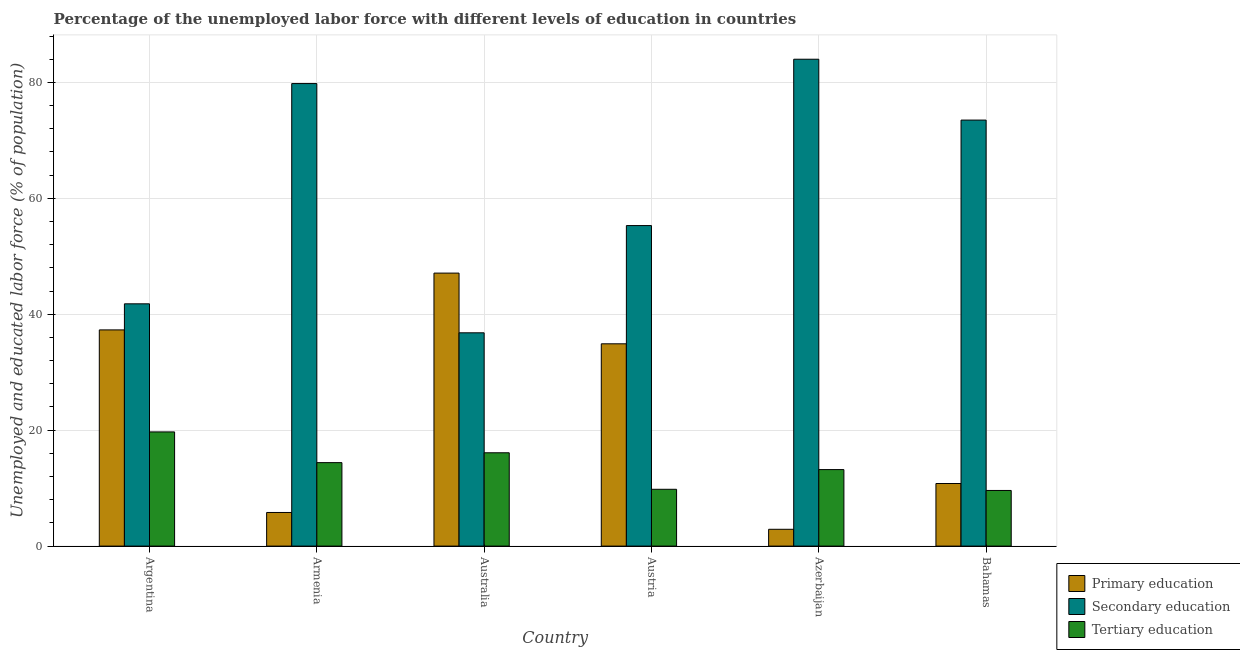How many different coloured bars are there?
Give a very brief answer. 3. How many groups of bars are there?
Provide a succinct answer. 6. How many bars are there on the 5th tick from the left?
Make the answer very short. 3. How many bars are there on the 3rd tick from the right?
Offer a very short reply. 3. What is the percentage of labor force who received secondary education in Australia?
Keep it short and to the point. 36.8. Across all countries, what is the maximum percentage of labor force who received secondary education?
Provide a short and direct response. 84. Across all countries, what is the minimum percentage of labor force who received secondary education?
Offer a terse response. 36.8. In which country was the percentage of labor force who received primary education minimum?
Ensure brevity in your answer.  Azerbaijan. What is the total percentage of labor force who received tertiary education in the graph?
Offer a terse response. 82.8. What is the difference between the percentage of labor force who received primary education in Argentina and that in Austria?
Offer a very short reply. 2.4. What is the difference between the percentage of labor force who received secondary education in Azerbaijan and the percentage of labor force who received primary education in Austria?
Your answer should be compact. 49.1. What is the average percentage of labor force who received secondary education per country?
Offer a very short reply. 61.87. What is the ratio of the percentage of labor force who received tertiary education in Azerbaijan to that in Bahamas?
Provide a succinct answer. 1.37. What is the difference between the highest and the second highest percentage of labor force who received tertiary education?
Offer a terse response. 3.6. What is the difference between the highest and the lowest percentage of labor force who received primary education?
Keep it short and to the point. 44.2. In how many countries, is the percentage of labor force who received primary education greater than the average percentage of labor force who received primary education taken over all countries?
Provide a succinct answer. 3. What does the 3rd bar from the left in Azerbaijan represents?
Keep it short and to the point. Tertiary education. What does the 2nd bar from the right in Austria represents?
Provide a succinct answer. Secondary education. Is it the case that in every country, the sum of the percentage of labor force who received primary education and percentage of labor force who received secondary education is greater than the percentage of labor force who received tertiary education?
Your answer should be very brief. Yes. How many bars are there?
Ensure brevity in your answer.  18. Are all the bars in the graph horizontal?
Your answer should be very brief. No. How many countries are there in the graph?
Make the answer very short. 6. How are the legend labels stacked?
Make the answer very short. Vertical. What is the title of the graph?
Give a very brief answer. Percentage of the unemployed labor force with different levels of education in countries. What is the label or title of the Y-axis?
Your response must be concise. Unemployed and educated labor force (% of population). What is the Unemployed and educated labor force (% of population) of Primary education in Argentina?
Your answer should be very brief. 37.3. What is the Unemployed and educated labor force (% of population) in Secondary education in Argentina?
Keep it short and to the point. 41.8. What is the Unemployed and educated labor force (% of population) in Tertiary education in Argentina?
Give a very brief answer. 19.7. What is the Unemployed and educated labor force (% of population) in Primary education in Armenia?
Offer a terse response. 5.8. What is the Unemployed and educated labor force (% of population) of Secondary education in Armenia?
Give a very brief answer. 79.8. What is the Unemployed and educated labor force (% of population) in Tertiary education in Armenia?
Keep it short and to the point. 14.4. What is the Unemployed and educated labor force (% of population) in Primary education in Australia?
Provide a short and direct response. 47.1. What is the Unemployed and educated labor force (% of population) in Secondary education in Australia?
Offer a very short reply. 36.8. What is the Unemployed and educated labor force (% of population) of Tertiary education in Australia?
Offer a very short reply. 16.1. What is the Unemployed and educated labor force (% of population) in Primary education in Austria?
Offer a very short reply. 34.9. What is the Unemployed and educated labor force (% of population) in Secondary education in Austria?
Make the answer very short. 55.3. What is the Unemployed and educated labor force (% of population) of Tertiary education in Austria?
Your answer should be very brief. 9.8. What is the Unemployed and educated labor force (% of population) in Primary education in Azerbaijan?
Give a very brief answer. 2.9. What is the Unemployed and educated labor force (% of population) in Tertiary education in Azerbaijan?
Your response must be concise. 13.2. What is the Unemployed and educated labor force (% of population) of Primary education in Bahamas?
Offer a very short reply. 10.8. What is the Unemployed and educated labor force (% of population) of Secondary education in Bahamas?
Provide a short and direct response. 73.5. What is the Unemployed and educated labor force (% of population) of Tertiary education in Bahamas?
Provide a short and direct response. 9.6. Across all countries, what is the maximum Unemployed and educated labor force (% of population) in Primary education?
Provide a succinct answer. 47.1. Across all countries, what is the maximum Unemployed and educated labor force (% of population) of Tertiary education?
Offer a terse response. 19.7. Across all countries, what is the minimum Unemployed and educated labor force (% of population) of Primary education?
Your answer should be compact. 2.9. Across all countries, what is the minimum Unemployed and educated labor force (% of population) in Secondary education?
Provide a short and direct response. 36.8. Across all countries, what is the minimum Unemployed and educated labor force (% of population) in Tertiary education?
Your answer should be compact. 9.6. What is the total Unemployed and educated labor force (% of population) in Primary education in the graph?
Offer a very short reply. 138.8. What is the total Unemployed and educated labor force (% of population) of Secondary education in the graph?
Your answer should be compact. 371.2. What is the total Unemployed and educated labor force (% of population) of Tertiary education in the graph?
Provide a short and direct response. 82.8. What is the difference between the Unemployed and educated labor force (% of population) of Primary education in Argentina and that in Armenia?
Your response must be concise. 31.5. What is the difference between the Unemployed and educated labor force (% of population) in Secondary education in Argentina and that in Armenia?
Provide a succinct answer. -38. What is the difference between the Unemployed and educated labor force (% of population) of Secondary education in Argentina and that in Australia?
Offer a terse response. 5. What is the difference between the Unemployed and educated labor force (% of population) in Secondary education in Argentina and that in Austria?
Your answer should be compact. -13.5. What is the difference between the Unemployed and educated labor force (% of population) of Primary education in Argentina and that in Azerbaijan?
Offer a terse response. 34.4. What is the difference between the Unemployed and educated labor force (% of population) in Secondary education in Argentina and that in Azerbaijan?
Your answer should be very brief. -42.2. What is the difference between the Unemployed and educated labor force (% of population) in Primary education in Argentina and that in Bahamas?
Make the answer very short. 26.5. What is the difference between the Unemployed and educated labor force (% of population) of Secondary education in Argentina and that in Bahamas?
Your answer should be compact. -31.7. What is the difference between the Unemployed and educated labor force (% of population) in Primary education in Armenia and that in Australia?
Ensure brevity in your answer.  -41.3. What is the difference between the Unemployed and educated labor force (% of population) in Tertiary education in Armenia and that in Australia?
Provide a short and direct response. -1.7. What is the difference between the Unemployed and educated labor force (% of population) in Primary education in Armenia and that in Austria?
Offer a terse response. -29.1. What is the difference between the Unemployed and educated labor force (% of population) in Primary education in Armenia and that in Azerbaijan?
Provide a short and direct response. 2.9. What is the difference between the Unemployed and educated labor force (% of population) of Primary education in Armenia and that in Bahamas?
Your answer should be very brief. -5. What is the difference between the Unemployed and educated labor force (% of population) in Secondary education in Armenia and that in Bahamas?
Provide a succinct answer. 6.3. What is the difference between the Unemployed and educated labor force (% of population) in Primary education in Australia and that in Austria?
Keep it short and to the point. 12.2. What is the difference between the Unemployed and educated labor force (% of population) of Secondary education in Australia and that in Austria?
Keep it short and to the point. -18.5. What is the difference between the Unemployed and educated labor force (% of population) in Primary education in Australia and that in Azerbaijan?
Provide a succinct answer. 44.2. What is the difference between the Unemployed and educated labor force (% of population) in Secondary education in Australia and that in Azerbaijan?
Offer a terse response. -47.2. What is the difference between the Unemployed and educated labor force (% of population) of Primary education in Australia and that in Bahamas?
Provide a short and direct response. 36.3. What is the difference between the Unemployed and educated labor force (% of population) in Secondary education in Australia and that in Bahamas?
Give a very brief answer. -36.7. What is the difference between the Unemployed and educated labor force (% of population) in Tertiary education in Australia and that in Bahamas?
Keep it short and to the point. 6.5. What is the difference between the Unemployed and educated labor force (% of population) in Secondary education in Austria and that in Azerbaijan?
Give a very brief answer. -28.7. What is the difference between the Unemployed and educated labor force (% of population) in Primary education in Austria and that in Bahamas?
Offer a very short reply. 24.1. What is the difference between the Unemployed and educated labor force (% of population) of Secondary education in Austria and that in Bahamas?
Make the answer very short. -18.2. What is the difference between the Unemployed and educated labor force (% of population) in Tertiary education in Austria and that in Bahamas?
Your response must be concise. 0.2. What is the difference between the Unemployed and educated labor force (% of population) in Primary education in Azerbaijan and that in Bahamas?
Ensure brevity in your answer.  -7.9. What is the difference between the Unemployed and educated labor force (% of population) in Tertiary education in Azerbaijan and that in Bahamas?
Provide a succinct answer. 3.6. What is the difference between the Unemployed and educated labor force (% of population) of Primary education in Argentina and the Unemployed and educated labor force (% of population) of Secondary education in Armenia?
Your response must be concise. -42.5. What is the difference between the Unemployed and educated labor force (% of population) of Primary education in Argentina and the Unemployed and educated labor force (% of population) of Tertiary education in Armenia?
Provide a short and direct response. 22.9. What is the difference between the Unemployed and educated labor force (% of population) in Secondary education in Argentina and the Unemployed and educated labor force (% of population) in Tertiary education in Armenia?
Your answer should be very brief. 27.4. What is the difference between the Unemployed and educated labor force (% of population) in Primary education in Argentina and the Unemployed and educated labor force (% of population) in Secondary education in Australia?
Your answer should be very brief. 0.5. What is the difference between the Unemployed and educated labor force (% of population) of Primary education in Argentina and the Unemployed and educated labor force (% of population) of Tertiary education in Australia?
Provide a succinct answer. 21.2. What is the difference between the Unemployed and educated labor force (% of population) of Secondary education in Argentina and the Unemployed and educated labor force (% of population) of Tertiary education in Australia?
Offer a very short reply. 25.7. What is the difference between the Unemployed and educated labor force (% of population) in Primary education in Argentina and the Unemployed and educated labor force (% of population) in Secondary education in Austria?
Your answer should be compact. -18. What is the difference between the Unemployed and educated labor force (% of population) in Primary education in Argentina and the Unemployed and educated labor force (% of population) in Tertiary education in Austria?
Provide a short and direct response. 27.5. What is the difference between the Unemployed and educated labor force (% of population) of Secondary education in Argentina and the Unemployed and educated labor force (% of population) of Tertiary education in Austria?
Provide a succinct answer. 32. What is the difference between the Unemployed and educated labor force (% of population) of Primary education in Argentina and the Unemployed and educated labor force (% of population) of Secondary education in Azerbaijan?
Your answer should be very brief. -46.7. What is the difference between the Unemployed and educated labor force (% of population) in Primary education in Argentina and the Unemployed and educated labor force (% of population) in Tertiary education in Azerbaijan?
Keep it short and to the point. 24.1. What is the difference between the Unemployed and educated labor force (% of population) in Secondary education in Argentina and the Unemployed and educated labor force (% of population) in Tertiary education in Azerbaijan?
Offer a very short reply. 28.6. What is the difference between the Unemployed and educated labor force (% of population) of Primary education in Argentina and the Unemployed and educated labor force (% of population) of Secondary education in Bahamas?
Keep it short and to the point. -36.2. What is the difference between the Unemployed and educated labor force (% of population) of Primary education in Argentina and the Unemployed and educated labor force (% of population) of Tertiary education in Bahamas?
Offer a very short reply. 27.7. What is the difference between the Unemployed and educated labor force (% of population) of Secondary education in Argentina and the Unemployed and educated labor force (% of population) of Tertiary education in Bahamas?
Offer a terse response. 32.2. What is the difference between the Unemployed and educated labor force (% of population) of Primary education in Armenia and the Unemployed and educated labor force (% of population) of Secondary education in Australia?
Offer a terse response. -31. What is the difference between the Unemployed and educated labor force (% of population) of Secondary education in Armenia and the Unemployed and educated labor force (% of population) of Tertiary education in Australia?
Your response must be concise. 63.7. What is the difference between the Unemployed and educated labor force (% of population) in Primary education in Armenia and the Unemployed and educated labor force (% of population) in Secondary education in Austria?
Ensure brevity in your answer.  -49.5. What is the difference between the Unemployed and educated labor force (% of population) of Primary education in Armenia and the Unemployed and educated labor force (% of population) of Secondary education in Azerbaijan?
Offer a very short reply. -78.2. What is the difference between the Unemployed and educated labor force (% of population) in Primary education in Armenia and the Unemployed and educated labor force (% of population) in Tertiary education in Azerbaijan?
Offer a very short reply. -7.4. What is the difference between the Unemployed and educated labor force (% of population) in Secondary education in Armenia and the Unemployed and educated labor force (% of population) in Tertiary education in Azerbaijan?
Make the answer very short. 66.6. What is the difference between the Unemployed and educated labor force (% of population) of Primary education in Armenia and the Unemployed and educated labor force (% of population) of Secondary education in Bahamas?
Your response must be concise. -67.7. What is the difference between the Unemployed and educated labor force (% of population) in Secondary education in Armenia and the Unemployed and educated labor force (% of population) in Tertiary education in Bahamas?
Your answer should be very brief. 70.2. What is the difference between the Unemployed and educated labor force (% of population) in Primary education in Australia and the Unemployed and educated labor force (% of population) in Tertiary education in Austria?
Give a very brief answer. 37.3. What is the difference between the Unemployed and educated labor force (% of population) of Secondary education in Australia and the Unemployed and educated labor force (% of population) of Tertiary education in Austria?
Give a very brief answer. 27. What is the difference between the Unemployed and educated labor force (% of population) in Primary education in Australia and the Unemployed and educated labor force (% of population) in Secondary education in Azerbaijan?
Ensure brevity in your answer.  -36.9. What is the difference between the Unemployed and educated labor force (% of population) in Primary education in Australia and the Unemployed and educated labor force (% of population) in Tertiary education in Azerbaijan?
Ensure brevity in your answer.  33.9. What is the difference between the Unemployed and educated labor force (% of population) of Secondary education in Australia and the Unemployed and educated labor force (% of population) of Tertiary education in Azerbaijan?
Your answer should be compact. 23.6. What is the difference between the Unemployed and educated labor force (% of population) of Primary education in Australia and the Unemployed and educated labor force (% of population) of Secondary education in Bahamas?
Give a very brief answer. -26.4. What is the difference between the Unemployed and educated labor force (% of population) of Primary education in Australia and the Unemployed and educated labor force (% of population) of Tertiary education in Bahamas?
Your response must be concise. 37.5. What is the difference between the Unemployed and educated labor force (% of population) of Secondary education in Australia and the Unemployed and educated labor force (% of population) of Tertiary education in Bahamas?
Provide a short and direct response. 27.2. What is the difference between the Unemployed and educated labor force (% of population) in Primary education in Austria and the Unemployed and educated labor force (% of population) in Secondary education in Azerbaijan?
Give a very brief answer. -49.1. What is the difference between the Unemployed and educated labor force (% of population) of Primary education in Austria and the Unemployed and educated labor force (% of population) of Tertiary education in Azerbaijan?
Provide a short and direct response. 21.7. What is the difference between the Unemployed and educated labor force (% of population) of Secondary education in Austria and the Unemployed and educated labor force (% of population) of Tertiary education in Azerbaijan?
Your answer should be compact. 42.1. What is the difference between the Unemployed and educated labor force (% of population) of Primary education in Austria and the Unemployed and educated labor force (% of population) of Secondary education in Bahamas?
Provide a short and direct response. -38.6. What is the difference between the Unemployed and educated labor force (% of population) in Primary education in Austria and the Unemployed and educated labor force (% of population) in Tertiary education in Bahamas?
Make the answer very short. 25.3. What is the difference between the Unemployed and educated labor force (% of population) in Secondary education in Austria and the Unemployed and educated labor force (% of population) in Tertiary education in Bahamas?
Ensure brevity in your answer.  45.7. What is the difference between the Unemployed and educated labor force (% of population) in Primary education in Azerbaijan and the Unemployed and educated labor force (% of population) in Secondary education in Bahamas?
Offer a terse response. -70.6. What is the difference between the Unemployed and educated labor force (% of population) of Primary education in Azerbaijan and the Unemployed and educated labor force (% of population) of Tertiary education in Bahamas?
Make the answer very short. -6.7. What is the difference between the Unemployed and educated labor force (% of population) in Secondary education in Azerbaijan and the Unemployed and educated labor force (% of population) in Tertiary education in Bahamas?
Ensure brevity in your answer.  74.4. What is the average Unemployed and educated labor force (% of population) of Primary education per country?
Give a very brief answer. 23.13. What is the average Unemployed and educated labor force (% of population) of Secondary education per country?
Your response must be concise. 61.87. What is the difference between the Unemployed and educated labor force (% of population) of Secondary education and Unemployed and educated labor force (% of population) of Tertiary education in Argentina?
Offer a terse response. 22.1. What is the difference between the Unemployed and educated labor force (% of population) of Primary education and Unemployed and educated labor force (% of population) of Secondary education in Armenia?
Your response must be concise. -74. What is the difference between the Unemployed and educated labor force (% of population) in Primary education and Unemployed and educated labor force (% of population) in Tertiary education in Armenia?
Offer a terse response. -8.6. What is the difference between the Unemployed and educated labor force (% of population) of Secondary education and Unemployed and educated labor force (% of population) of Tertiary education in Armenia?
Provide a succinct answer. 65.4. What is the difference between the Unemployed and educated labor force (% of population) in Primary education and Unemployed and educated labor force (% of population) in Secondary education in Australia?
Make the answer very short. 10.3. What is the difference between the Unemployed and educated labor force (% of population) in Primary education and Unemployed and educated labor force (% of population) in Tertiary education in Australia?
Keep it short and to the point. 31. What is the difference between the Unemployed and educated labor force (% of population) in Secondary education and Unemployed and educated labor force (% of population) in Tertiary education in Australia?
Ensure brevity in your answer.  20.7. What is the difference between the Unemployed and educated labor force (% of population) of Primary education and Unemployed and educated labor force (% of population) of Secondary education in Austria?
Give a very brief answer. -20.4. What is the difference between the Unemployed and educated labor force (% of population) in Primary education and Unemployed and educated labor force (% of population) in Tertiary education in Austria?
Provide a short and direct response. 25.1. What is the difference between the Unemployed and educated labor force (% of population) of Secondary education and Unemployed and educated labor force (% of population) of Tertiary education in Austria?
Keep it short and to the point. 45.5. What is the difference between the Unemployed and educated labor force (% of population) in Primary education and Unemployed and educated labor force (% of population) in Secondary education in Azerbaijan?
Your response must be concise. -81.1. What is the difference between the Unemployed and educated labor force (% of population) of Primary education and Unemployed and educated labor force (% of population) of Tertiary education in Azerbaijan?
Provide a short and direct response. -10.3. What is the difference between the Unemployed and educated labor force (% of population) in Secondary education and Unemployed and educated labor force (% of population) in Tertiary education in Azerbaijan?
Your response must be concise. 70.8. What is the difference between the Unemployed and educated labor force (% of population) in Primary education and Unemployed and educated labor force (% of population) in Secondary education in Bahamas?
Give a very brief answer. -62.7. What is the difference between the Unemployed and educated labor force (% of population) of Secondary education and Unemployed and educated labor force (% of population) of Tertiary education in Bahamas?
Your answer should be compact. 63.9. What is the ratio of the Unemployed and educated labor force (% of population) of Primary education in Argentina to that in Armenia?
Offer a terse response. 6.43. What is the ratio of the Unemployed and educated labor force (% of population) in Secondary education in Argentina to that in Armenia?
Give a very brief answer. 0.52. What is the ratio of the Unemployed and educated labor force (% of population) in Tertiary education in Argentina to that in Armenia?
Make the answer very short. 1.37. What is the ratio of the Unemployed and educated labor force (% of population) of Primary education in Argentina to that in Australia?
Your answer should be very brief. 0.79. What is the ratio of the Unemployed and educated labor force (% of population) in Secondary education in Argentina to that in Australia?
Make the answer very short. 1.14. What is the ratio of the Unemployed and educated labor force (% of population) in Tertiary education in Argentina to that in Australia?
Offer a very short reply. 1.22. What is the ratio of the Unemployed and educated labor force (% of population) in Primary education in Argentina to that in Austria?
Ensure brevity in your answer.  1.07. What is the ratio of the Unemployed and educated labor force (% of population) in Secondary education in Argentina to that in Austria?
Your response must be concise. 0.76. What is the ratio of the Unemployed and educated labor force (% of population) in Tertiary education in Argentina to that in Austria?
Your answer should be very brief. 2.01. What is the ratio of the Unemployed and educated labor force (% of population) in Primary education in Argentina to that in Azerbaijan?
Ensure brevity in your answer.  12.86. What is the ratio of the Unemployed and educated labor force (% of population) in Secondary education in Argentina to that in Azerbaijan?
Make the answer very short. 0.5. What is the ratio of the Unemployed and educated labor force (% of population) in Tertiary education in Argentina to that in Azerbaijan?
Make the answer very short. 1.49. What is the ratio of the Unemployed and educated labor force (% of population) of Primary education in Argentina to that in Bahamas?
Your response must be concise. 3.45. What is the ratio of the Unemployed and educated labor force (% of population) in Secondary education in Argentina to that in Bahamas?
Your answer should be very brief. 0.57. What is the ratio of the Unemployed and educated labor force (% of population) in Tertiary education in Argentina to that in Bahamas?
Offer a terse response. 2.05. What is the ratio of the Unemployed and educated labor force (% of population) in Primary education in Armenia to that in Australia?
Provide a succinct answer. 0.12. What is the ratio of the Unemployed and educated labor force (% of population) in Secondary education in Armenia to that in Australia?
Ensure brevity in your answer.  2.17. What is the ratio of the Unemployed and educated labor force (% of population) in Tertiary education in Armenia to that in Australia?
Keep it short and to the point. 0.89. What is the ratio of the Unemployed and educated labor force (% of population) in Primary education in Armenia to that in Austria?
Provide a succinct answer. 0.17. What is the ratio of the Unemployed and educated labor force (% of population) of Secondary education in Armenia to that in Austria?
Make the answer very short. 1.44. What is the ratio of the Unemployed and educated labor force (% of population) of Tertiary education in Armenia to that in Austria?
Provide a succinct answer. 1.47. What is the ratio of the Unemployed and educated labor force (% of population) of Secondary education in Armenia to that in Azerbaijan?
Your response must be concise. 0.95. What is the ratio of the Unemployed and educated labor force (% of population) in Tertiary education in Armenia to that in Azerbaijan?
Your answer should be very brief. 1.09. What is the ratio of the Unemployed and educated labor force (% of population) of Primary education in Armenia to that in Bahamas?
Ensure brevity in your answer.  0.54. What is the ratio of the Unemployed and educated labor force (% of population) in Secondary education in Armenia to that in Bahamas?
Keep it short and to the point. 1.09. What is the ratio of the Unemployed and educated labor force (% of population) in Primary education in Australia to that in Austria?
Provide a succinct answer. 1.35. What is the ratio of the Unemployed and educated labor force (% of population) in Secondary education in Australia to that in Austria?
Your response must be concise. 0.67. What is the ratio of the Unemployed and educated labor force (% of population) of Tertiary education in Australia to that in Austria?
Provide a succinct answer. 1.64. What is the ratio of the Unemployed and educated labor force (% of population) of Primary education in Australia to that in Azerbaijan?
Offer a terse response. 16.24. What is the ratio of the Unemployed and educated labor force (% of population) in Secondary education in Australia to that in Azerbaijan?
Give a very brief answer. 0.44. What is the ratio of the Unemployed and educated labor force (% of population) of Tertiary education in Australia to that in Azerbaijan?
Provide a short and direct response. 1.22. What is the ratio of the Unemployed and educated labor force (% of population) in Primary education in Australia to that in Bahamas?
Your answer should be compact. 4.36. What is the ratio of the Unemployed and educated labor force (% of population) in Secondary education in Australia to that in Bahamas?
Provide a succinct answer. 0.5. What is the ratio of the Unemployed and educated labor force (% of population) in Tertiary education in Australia to that in Bahamas?
Offer a terse response. 1.68. What is the ratio of the Unemployed and educated labor force (% of population) in Primary education in Austria to that in Azerbaijan?
Give a very brief answer. 12.03. What is the ratio of the Unemployed and educated labor force (% of population) of Secondary education in Austria to that in Azerbaijan?
Give a very brief answer. 0.66. What is the ratio of the Unemployed and educated labor force (% of population) of Tertiary education in Austria to that in Azerbaijan?
Offer a terse response. 0.74. What is the ratio of the Unemployed and educated labor force (% of population) in Primary education in Austria to that in Bahamas?
Give a very brief answer. 3.23. What is the ratio of the Unemployed and educated labor force (% of population) of Secondary education in Austria to that in Bahamas?
Your answer should be very brief. 0.75. What is the ratio of the Unemployed and educated labor force (% of population) of Tertiary education in Austria to that in Bahamas?
Offer a terse response. 1.02. What is the ratio of the Unemployed and educated labor force (% of population) of Primary education in Azerbaijan to that in Bahamas?
Your answer should be very brief. 0.27. What is the ratio of the Unemployed and educated labor force (% of population) of Tertiary education in Azerbaijan to that in Bahamas?
Give a very brief answer. 1.38. What is the difference between the highest and the second highest Unemployed and educated labor force (% of population) of Primary education?
Offer a very short reply. 9.8. What is the difference between the highest and the second highest Unemployed and educated labor force (% of population) in Secondary education?
Your response must be concise. 4.2. What is the difference between the highest and the lowest Unemployed and educated labor force (% of population) in Primary education?
Make the answer very short. 44.2. What is the difference between the highest and the lowest Unemployed and educated labor force (% of population) in Secondary education?
Provide a succinct answer. 47.2. What is the difference between the highest and the lowest Unemployed and educated labor force (% of population) of Tertiary education?
Provide a short and direct response. 10.1. 